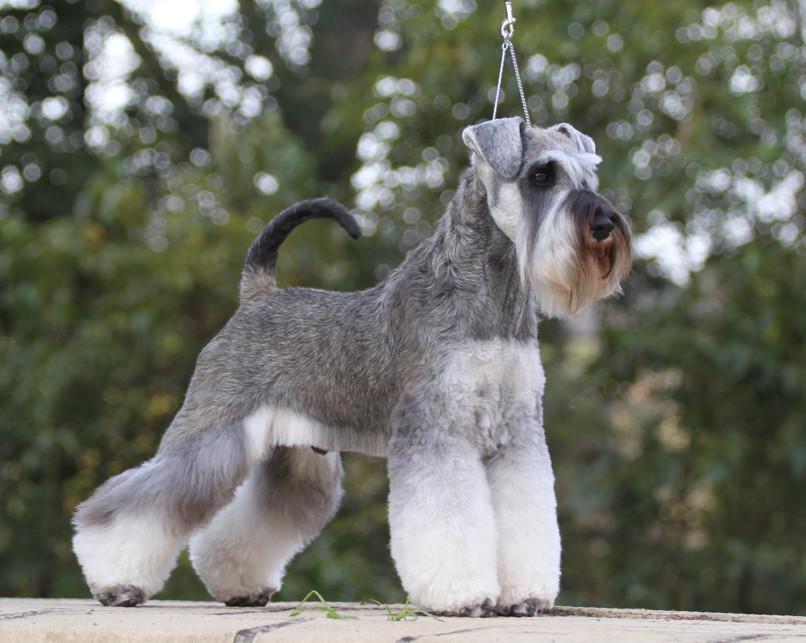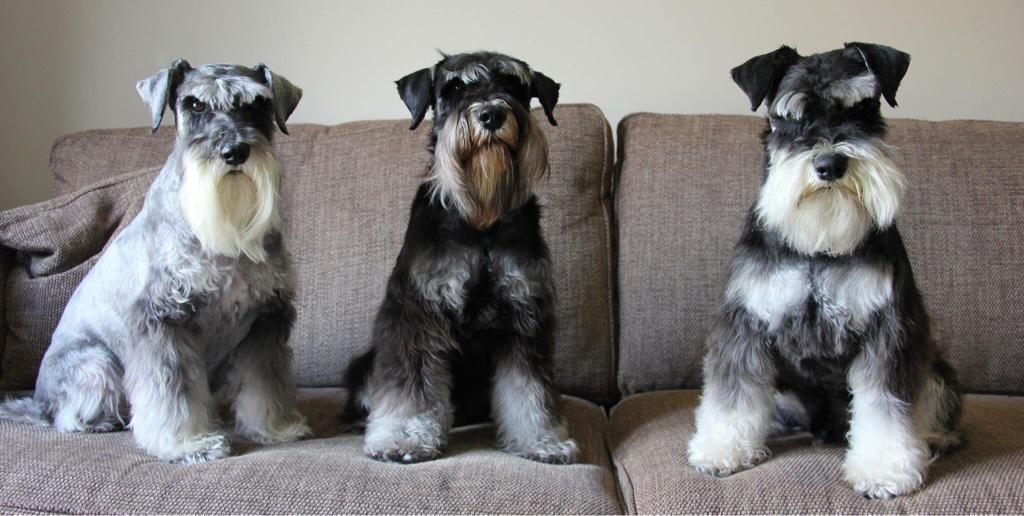The first image is the image on the left, the second image is the image on the right. Given the left and right images, does the statement "a dog is posing with a taught loop around it's neck" hold true? Answer yes or no. Yes. The first image is the image on the left, the second image is the image on the right. Analyze the images presented: Is the assertion "There are three Schnauzers in one image, and one in the other." valid? Answer yes or no. Yes. 